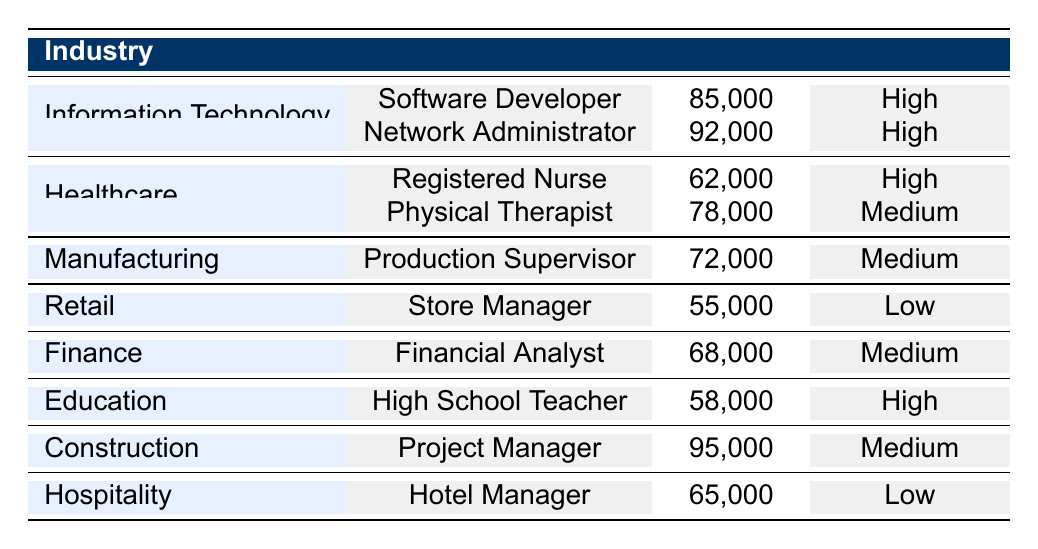What is the highest salary in the Healthcare industry? The table lists two job titles in the Healthcare industry: Registered Nurse with a salary of 62,000 and Physical Therapist with a salary of 78,000. Comparing these two, the highest salary is 78,000 for the Physical Therapist.
Answer: 78,000 Which industry has the lowest average salary based on the data provided? To find the average salary of each industry, we can add the salaries of the jobs in each industry and divide by the number of jobs in that industry. For Retail: (55,000) = 55,000. For Healthcare: (62,000 + 78,000) / 2 = 70,000. For Manufacturing: (72,000) = 72,000. For Education: (58,000) = 58,000. For Hospitality: (65,000) = 65,000. For Finance: (68,000) = 68,000. For Information Technology: (85,000 + 92,000) / 2 = 88,500. For Construction: (95,000) = 95,000. The lowest average salary is in the Retail industry with 55,000.
Answer: Retail Is the job security in the Information Technology industry high for all job titles listed? The table shows two job titles in the Information Technology industry: Software Developer with high job security and Network Administrator also with high job security. Therefore, the answer is yes, both job titles have high job security.
Answer: Yes What is the total salary for all professions in the Manufacturing industry? The Manufacturing industry has one job title listed, Production Supervisor with a salary of 72,000. Since there is only one job title, the total salary for the Manufacturing industry is 72,000.
Answer: 72,000 Which job title has the highest salary among all the job titles listed in the table? The table shows the highest salaries for various job titles: Software Developer (85,000), Network Administrator (92,000), Registered Nurse (62,000), Physical Therapist (78,000), Production Supervisor (72,000), Store Manager (55,000), Financial Analyst (68,000), High School Teacher (58,000), Project Manager (95,000), and Hotel Manager (65,000). Among these, Project Manager (95,000) has the highest salary.
Answer: Project Manager (95,000) 